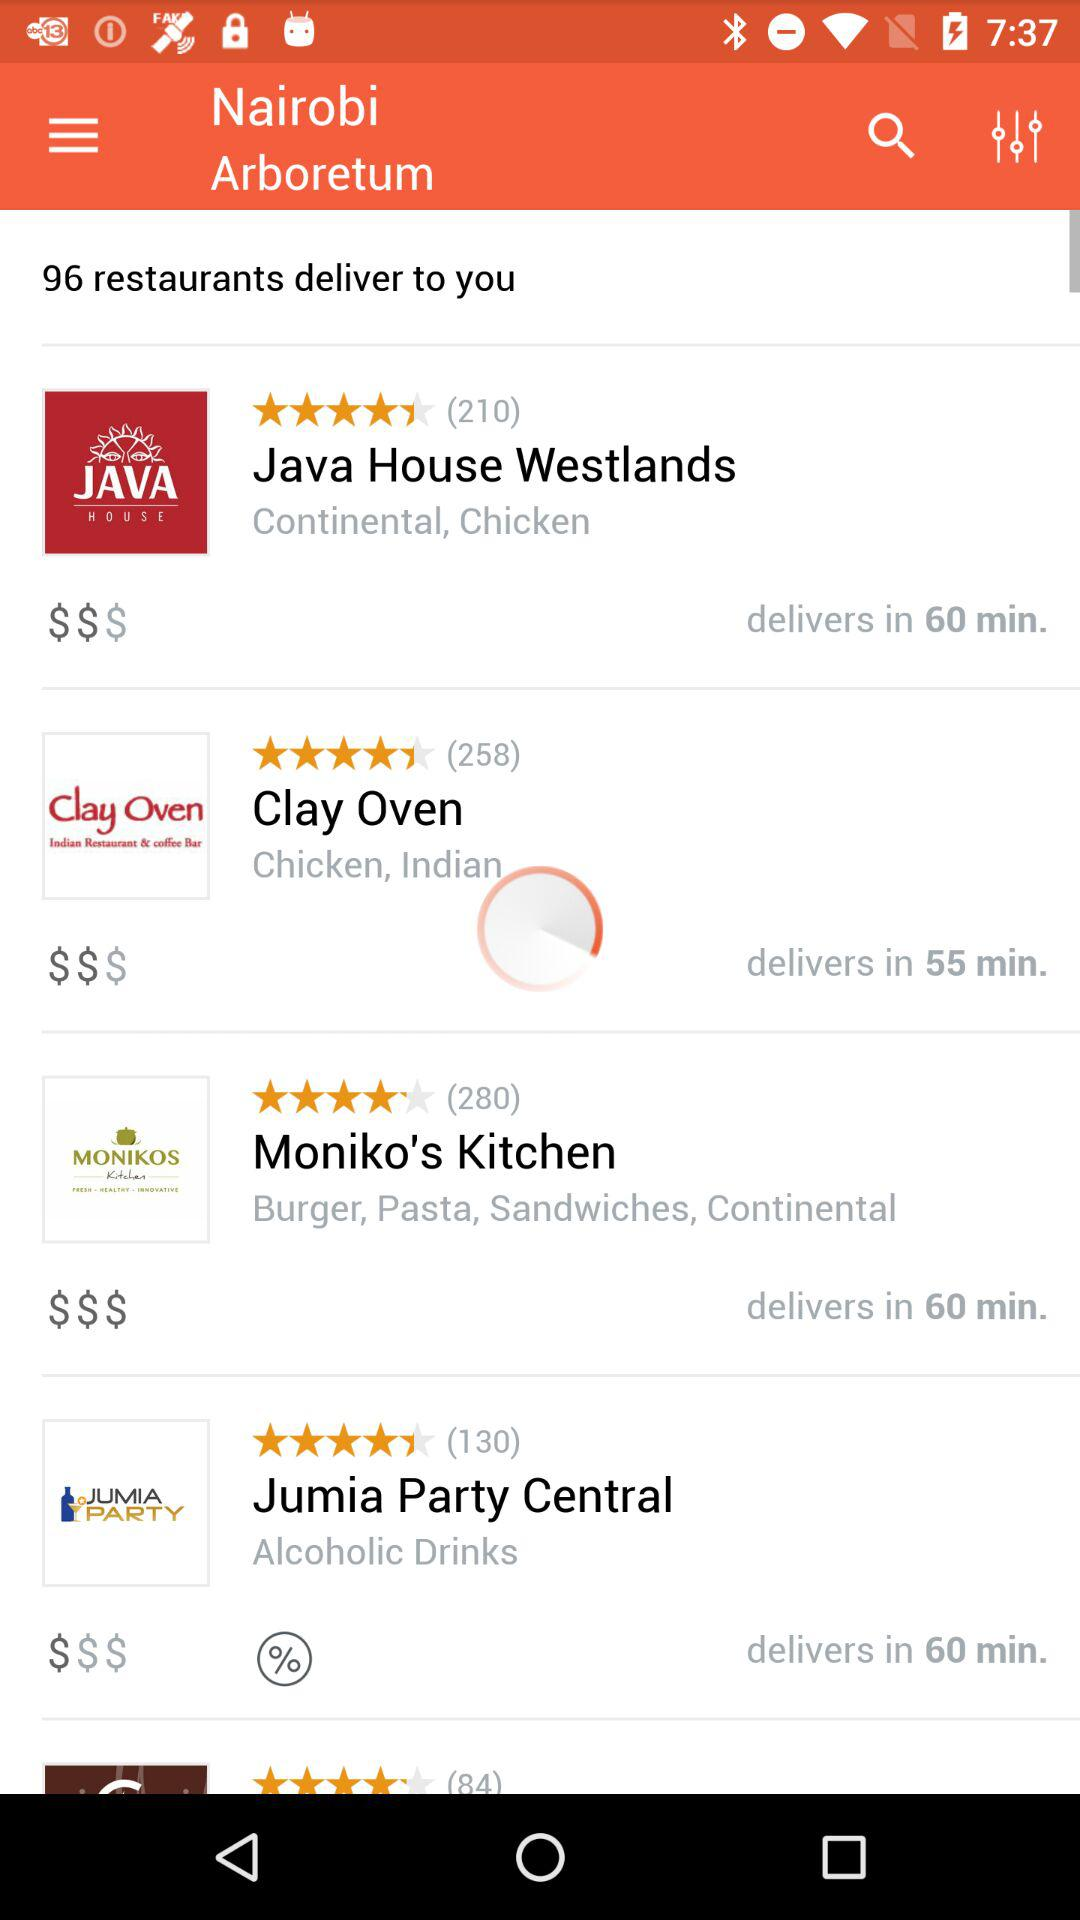What type of cuisine is served by Java House Westlands? Java House Westlands serves continental and chicken. 